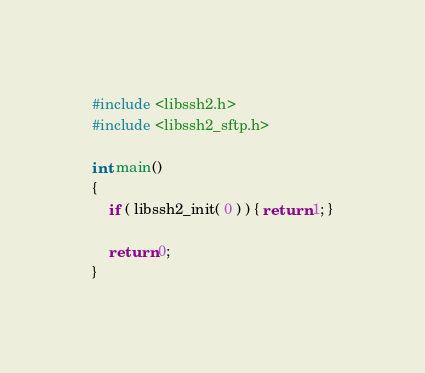<code> <loc_0><loc_0><loc_500><loc_500><_C++_>#include <libssh2.h>
#include <libssh2_sftp.h>

int main()
{
	if ( libssh2_init( 0 ) ) { return 1; }

	return 0;
}

</code> 